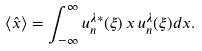<formula> <loc_0><loc_0><loc_500><loc_500>\langle { \hat { x } } \rangle = \int _ { - \infty } ^ { \infty } u _ { n } ^ { \lambda * } ( \xi ) \, x \, u _ { n } ^ { \lambda } ( \xi ) d x .</formula> 